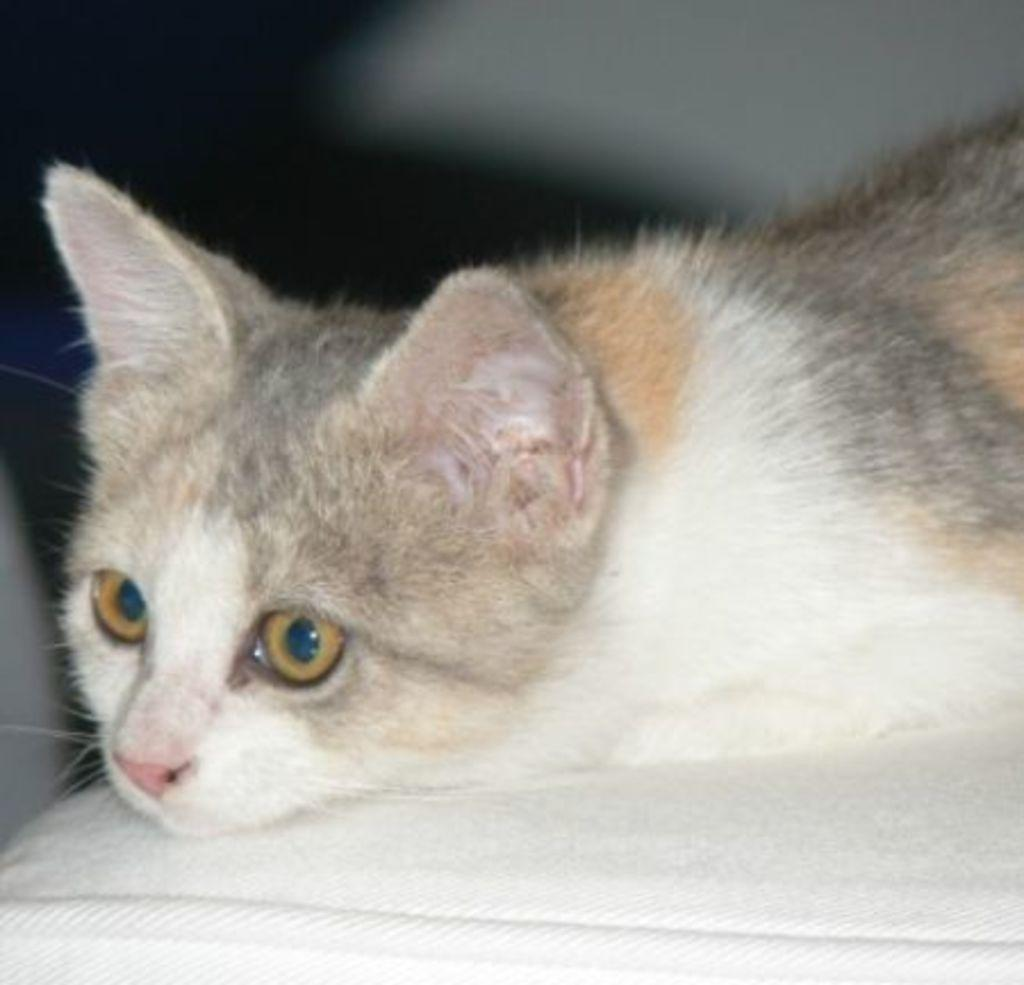What type of animal is in the image? There is a cat in the image. What is the cat doing in the image? The cat is laying on a white object. What time is displayed on the watch in the image? There is no watch present in the image; it only features a cat laying on a white object. 